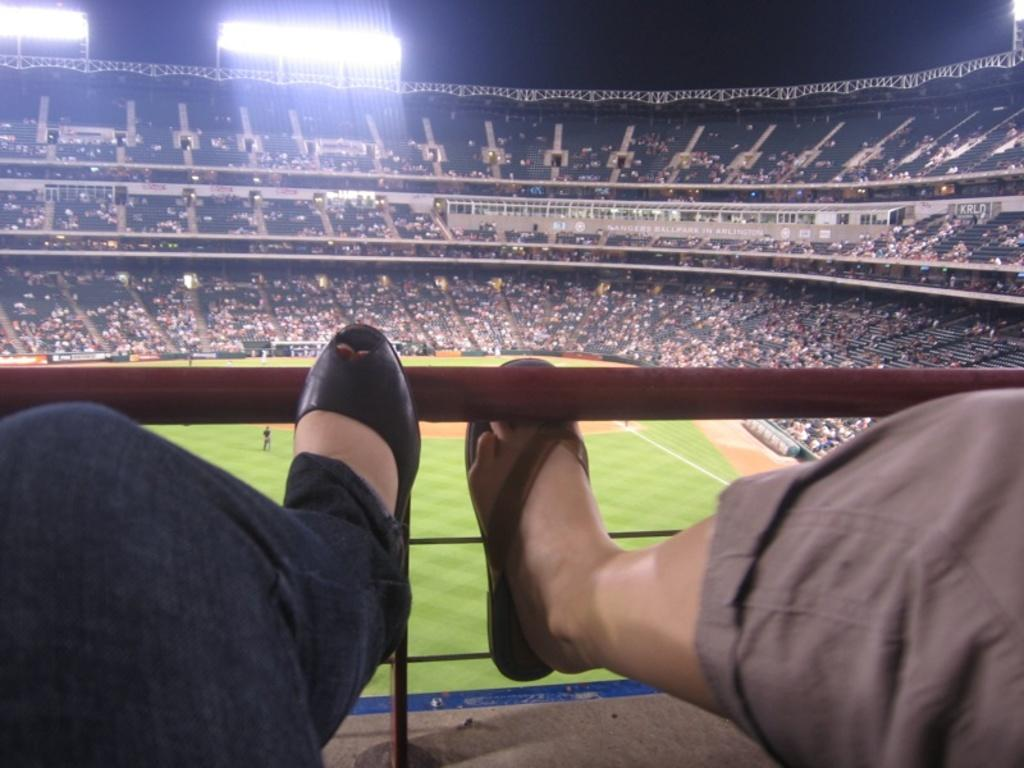What type of structure is shown in the image? There is a stadium in the image. Can you describe the position of the two persons in the image? The legs of two persons are on iron grilles. What is the third person in the image doing? There is a person standing on the ground. What can be seen at the top of the image? Floodlights are visible at the top of the image. Can you see a parrot flying over the ocean in the image? There is no parrot or ocean present in the image; it features a person sitting and reading a book. 